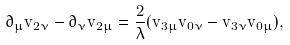Convert formula to latex. <formula><loc_0><loc_0><loc_500><loc_500>\partial _ { \mu } v _ { 2 \nu } - \partial _ { \nu } v _ { 2 \mu } = \frac { 2 } { \lambda } ( v _ { 3 \mu } v _ { 0 \nu } - v _ { 3 \nu } v _ { 0 \mu } ) ,</formula> 